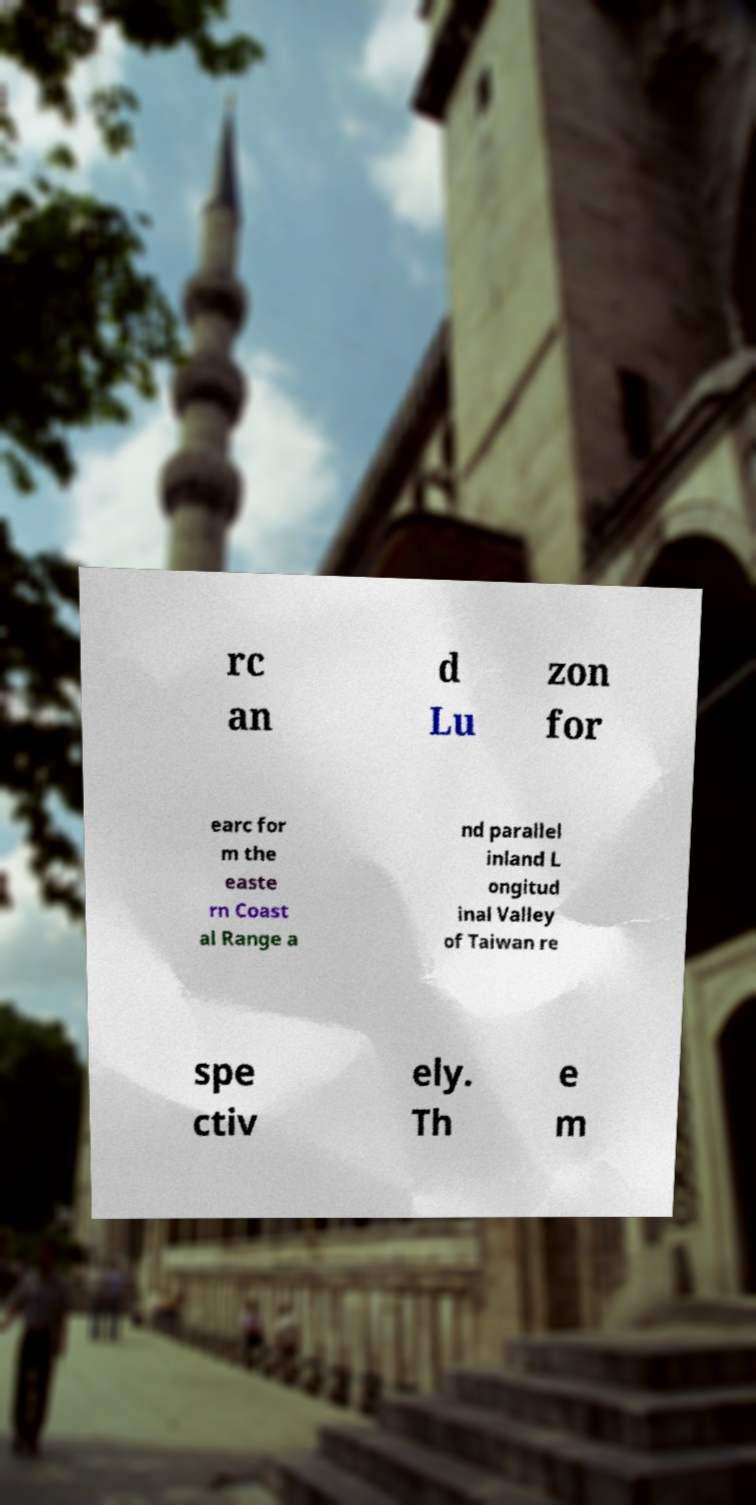Can you read and provide the text displayed in the image?This photo seems to have some interesting text. Can you extract and type it out for me? rc an d Lu zon for earc for m the easte rn Coast al Range a nd parallel inland L ongitud inal Valley of Taiwan re spe ctiv ely. Th e m 